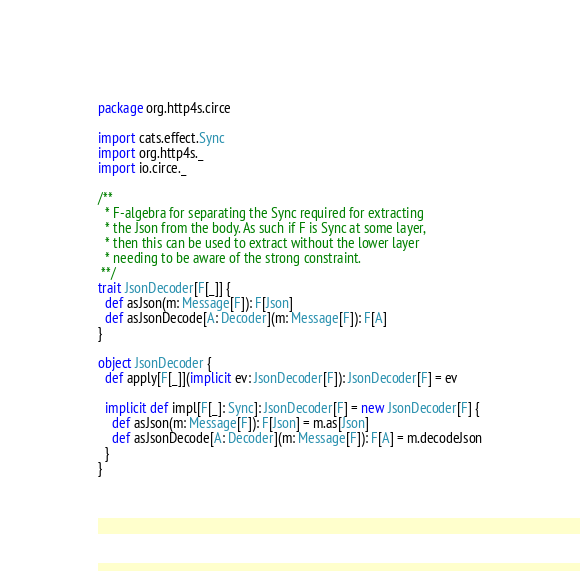<code> <loc_0><loc_0><loc_500><loc_500><_Scala_>package org.http4s.circe

import cats.effect.Sync
import org.http4s._
import io.circe._

/**
  * F-algebra for separating the Sync required for extracting
  * the Json from the body. As such if F is Sync at some layer,
  * then this can be used to extract without the lower layer
  * needing to be aware of the strong constraint.
 **/
trait JsonDecoder[F[_]] {
  def asJson(m: Message[F]): F[Json]
  def asJsonDecode[A: Decoder](m: Message[F]): F[A]
}

object JsonDecoder {
  def apply[F[_]](implicit ev: JsonDecoder[F]): JsonDecoder[F] = ev

  implicit def impl[F[_]: Sync]: JsonDecoder[F] = new JsonDecoder[F] {
    def asJson(m: Message[F]): F[Json] = m.as[Json]
    def asJsonDecode[A: Decoder](m: Message[F]): F[A] = m.decodeJson
  }
}
</code> 